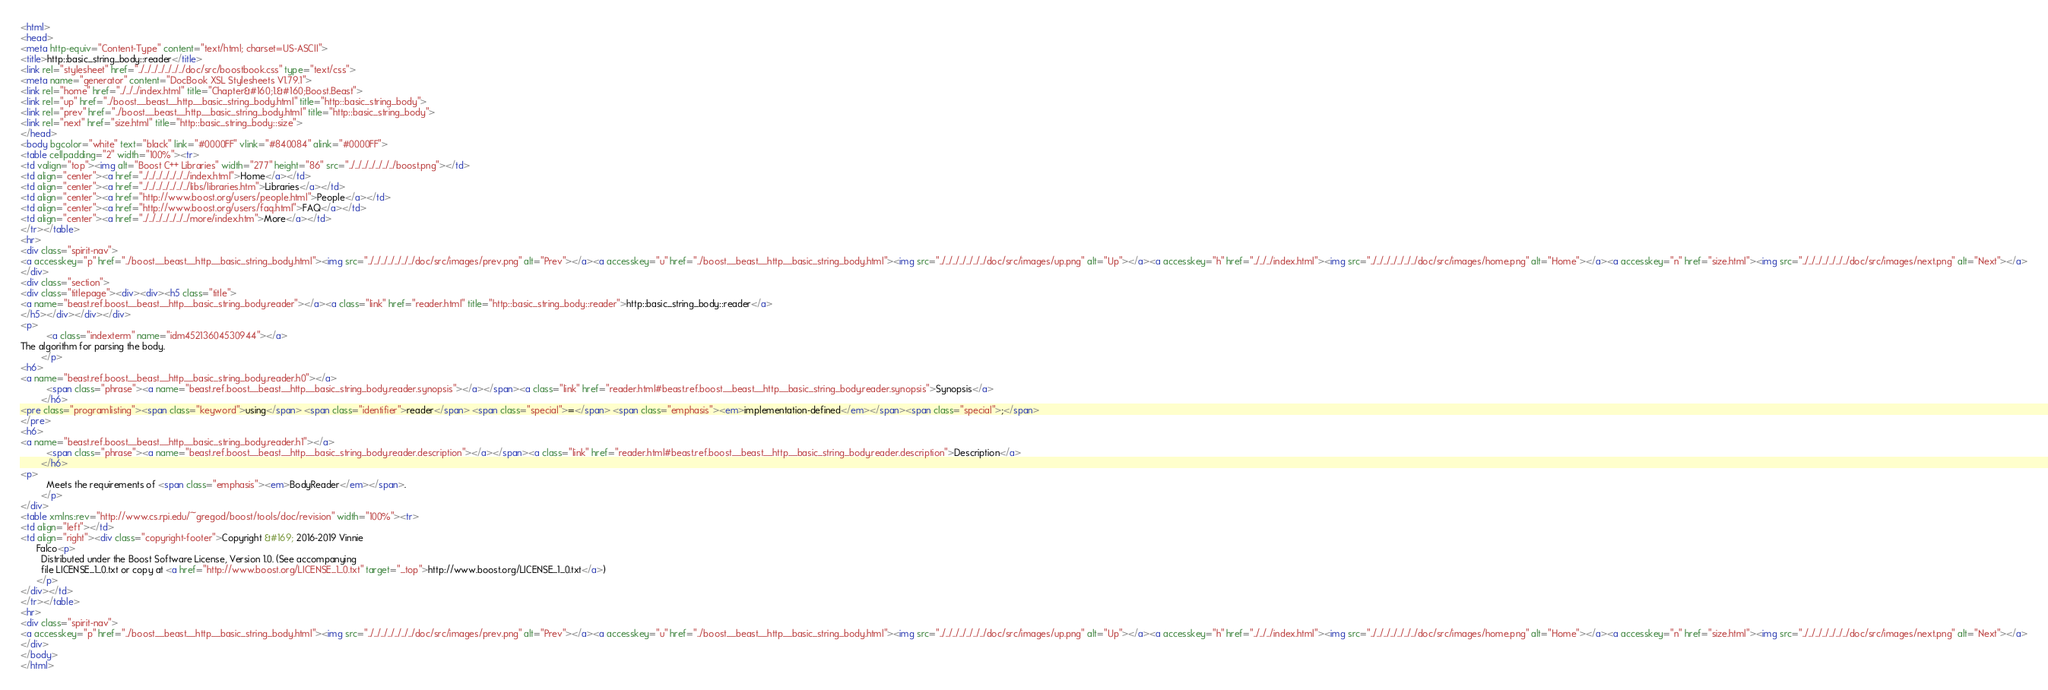Convert code to text. <code><loc_0><loc_0><loc_500><loc_500><_HTML_><html>
<head>
<meta http-equiv="Content-Type" content="text/html; charset=US-ASCII">
<title>http::basic_string_body::reader</title>
<link rel="stylesheet" href="../../../../../../../doc/src/boostbook.css" type="text/css">
<meta name="generator" content="DocBook XSL Stylesheets V1.79.1">
<link rel="home" href="../../../index.html" title="Chapter&#160;1.&#160;Boost.Beast">
<link rel="up" href="../boost__beast__http__basic_string_body.html" title="http::basic_string_body">
<link rel="prev" href="../boost__beast__http__basic_string_body.html" title="http::basic_string_body">
<link rel="next" href="size.html" title="http::basic_string_body::size">
</head>
<body bgcolor="white" text="black" link="#0000FF" vlink="#840084" alink="#0000FF">
<table cellpadding="2" width="100%"><tr>
<td valign="top"><img alt="Boost C++ Libraries" width="277" height="86" src="../../../../../../../boost.png"></td>
<td align="center"><a href="../../../../../../../index.html">Home</a></td>
<td align="center"><a href="../../../../../../../libs/libraries.htm">Libraries</a></td>
<td align="center"><a href="http://www.boost.org/users/people.html">People</a></td>
<td align="center"><a href="http://www.boost.org/users/faq.html">FAQ</a></td>
<td align="center"><a href="../../../../../../../more/index.htm">More</a></td>
</tr></table>
<hr>
<div class="spirit-nav">
<a accesskey="p" href="../boost__beast__http__basic_string_body.html"><img src="../../../../../../../doc/src/images/prev.png" alt="Prev"></a><a accesskey="u" href="../boost__beast__http__basic_string_body.html"><img src="../../../../../../../doc/src/images/up.png" alt="Up"></a><a accesskey="h" href="../../../index.html"><img src="../../../../../../../doc/src/images/home.png" alt="Home"></a><a accesskey="n" href="size.html"><img src="../../../../../../../doc/src/images/next.png" alt="Next"></a>
</div>
<div class="section">
<div class="titlepage"><div><div><h5 class="title">
<a name="beast.ref.boost__beast__http__basic_string_body.reader"></a><a class="link" href="reader.html" title="http::basic_string_body::reader">http::basic_string_body::reader</a>
</h5></div></div></div>
<p>
          <a class="indexterm" name="idm45213604530944"></a>
The algorithm for parsing the body.
        </p>
<h6>
<a name="beast.ref.boost__beast__http__basic_string_body.reader.h0"></a>
          <span class="phrase"><a name="beast.ref.boost__beast__http__basic_string_body.reader.synopsis"></a></span><a class="link" href="reader.html#beast.ref.boost__beast__http__basic_string_body.reader.synopsis">Synopsis</a>
        </h6>
<pre class="programlisting"><span class="keyword">using</span> <span class="identifier">reader</span> <span class="special">=</span> <span class="emphasis"><em>implementation-defined</em></span><span class="special">;</span>
</pre>
<h6>
<a name="beast.ref.boost__beast__http__basic_string_body.reader.h1"></a>
          <span class="phrase"><a name="beast.ref.boost__beast__http__basic_string_body.reader.description"></a></span><a class="link" href="reader.html#beast.ref.boost__beast__http__basic_string_body.reader.description">Description</a>
        </h6>
<p>
          Meets the requirements of <span class="emphasis"><em>BodyReader</em></span>.
        </p>
</div>
<table xmlns:rev="http://www.cs.rpi.edu/~gregod/boost/tools/doc/revision" width="100%"><tr>
<td align="left"></td>
<td align="right"><div class="copyright-footer">Copyright &#169; 2016-2019 Vinnie
      Falco<p>
        Distributed under the Boost Software License, Version 1.0. (See accompanying
        file LICENSE_1_0.txt or copy at <a href="http://www.boost.org/LICENSE_1_0.txt" target="_top">http://www.boost.org/LICENSE_1_0.txt</a>)
      </p>
</div></td>
</tr></table>
<hr>
<div class="spirit-nav">
<a accesskey="p" href="../boost__beast__http__basic_string_body.html"><img src="../../../../../../../doc/src/images/prev.png" alt="Prev"></a><a accesskey="u" href="../boost__beast__http__basic_string_body.html"><img src="../../../../../../../doc/src/images/up.png" alt="Up"></a><a accesskey="h" href="../../../index.html"><img src="../../../../../../../doc/src/images/home.png" alt="Home"></a><a accesskey="n" href="size.html"><img src="../../../../../../../doc/src/images/next.png" alt="Next"></a>
</div>
</body>
</html>
</code> 